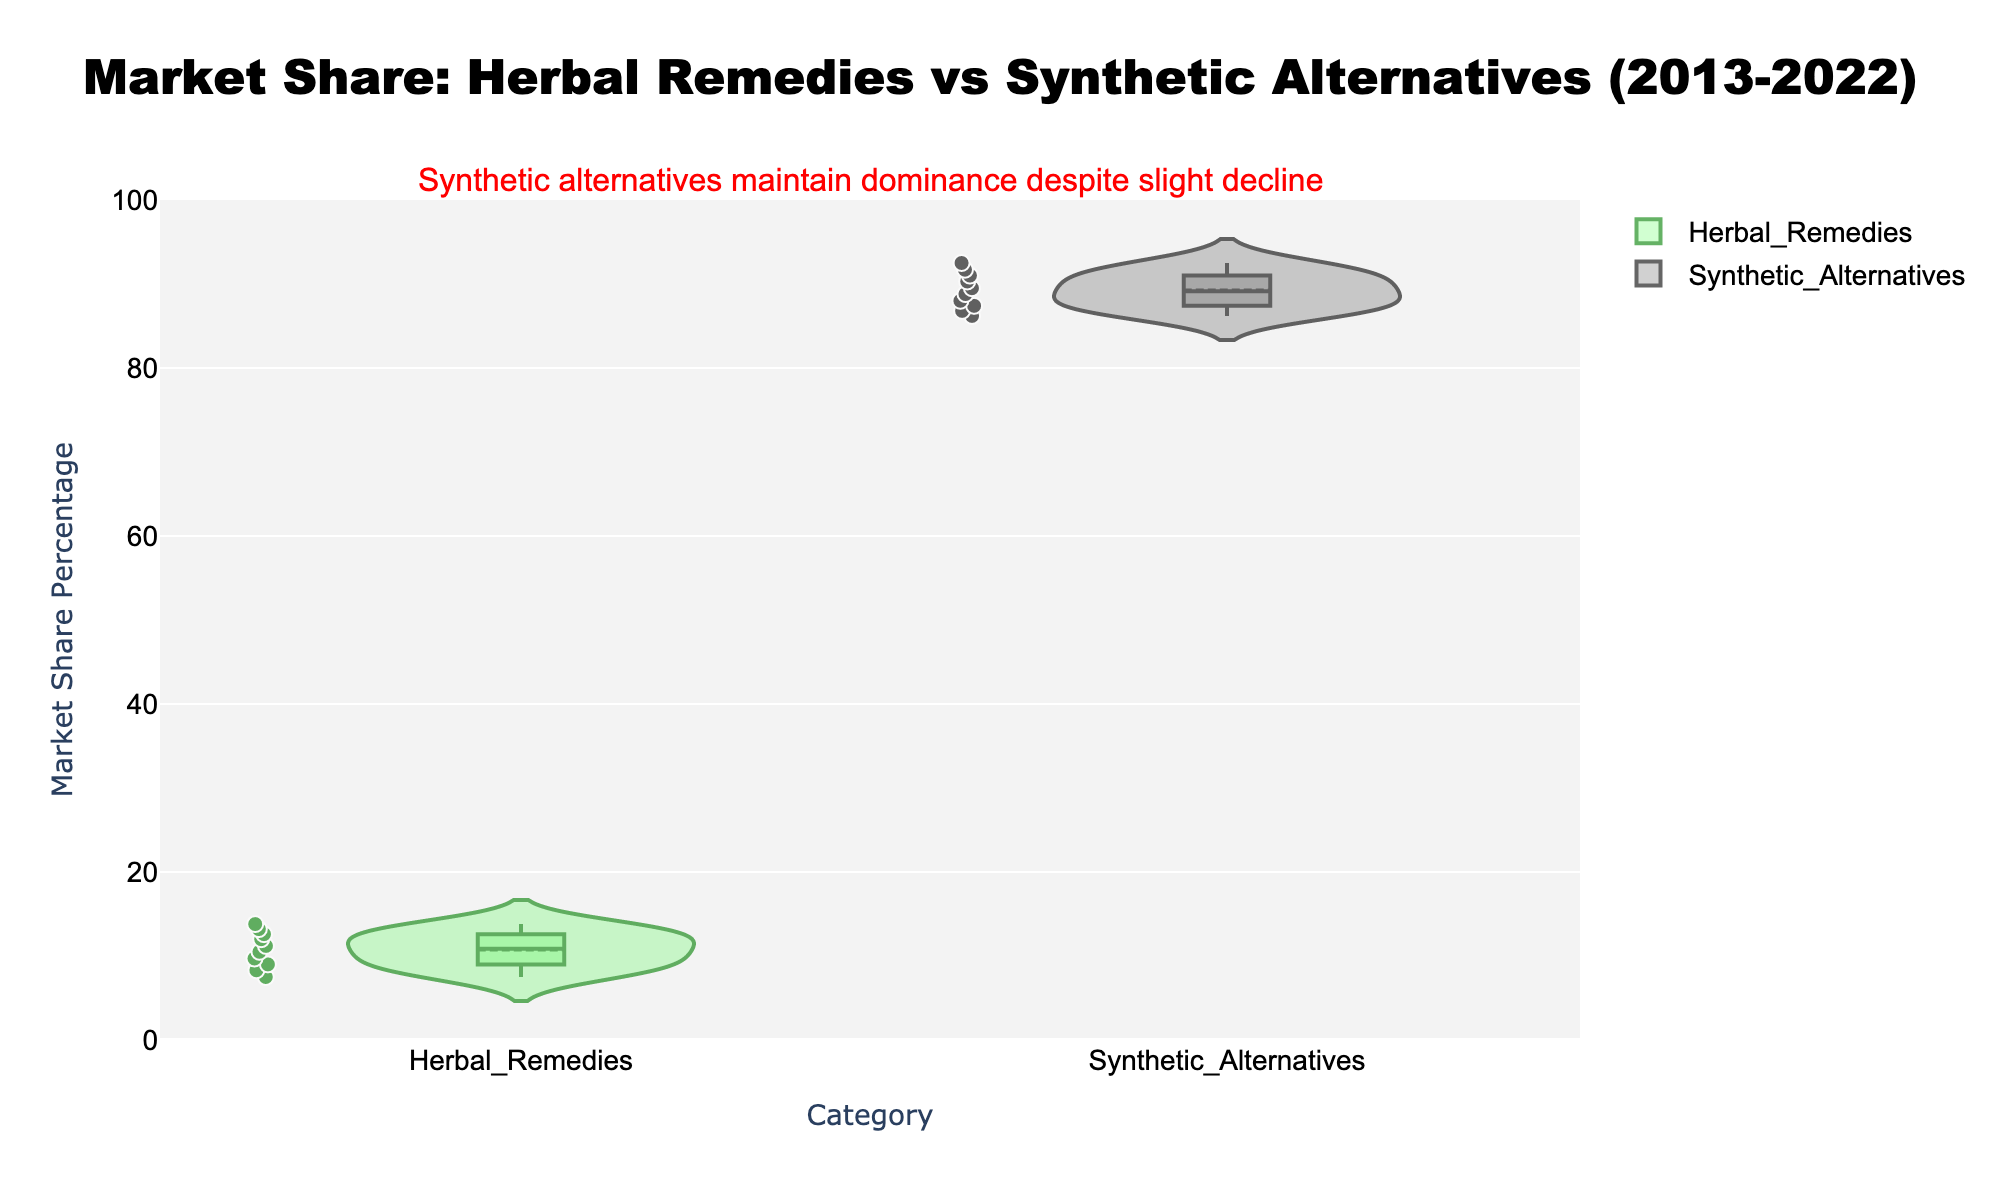What is the title of the figure? The title is typically found at the very top of the figure and describes what the plot is showing. In this case, we can see the title "Market Share: Herbal Remedies vs Synthetic Alternatives (2013-2022)".
Answer: Market Share: Herbal Remedies vs Synthetic Alternatives (2013-2022) What are the two categories compared in the figure? The x-axis of the figure represents the categories being compared, and in this case, they are labeled as "Herbal Remedies" and "Synthetic Alternatives".
Answer: Herbal Remedies and Synthetic Alternatives What is the trend in market share for Herbal Remedies over the years 2013 to 2022? By observing the box plot overlay within the violin plot for Herbal Remedies, we can see a general upward trend in market share percentages over the years. It starts from a lower distribution and gradually shifts upward.
Answer: Upward trend Which category has a higher market share percentage overall? The figure's y-axis indicates market share percentages, and by comparison, Synthetic Alternatives consistently have a higher market share percentage throughout the decade.
Answer: Synthetic Alternatives What is the color used to represent Synthetic Alternatives in the plot? The color of the lines and markers for Synthetic Alternatives is black, as specified in the visual design. The fill color is also greyish to denote a contrast with Herbal Remedies.
Answer: Black (with greyish fill) What is the mean market share percentage for Herbal Remedies as shown in the plot? The mean line is visible within the violin plot for Herbal Remedies. Observing its position, the mean market share percentage for Herbal Remedies over the decade is around 11.58%.
Answer: 11.58% How does the quartile distribution for Synthetic Alternatives compare to that of Herbal Remedies? The box plot within the violin plot shows the interquartile ranges: the boxes for Synthetic Alternatives are positioned higher with narrower distributions compared to those for Herbal Remedies, indicating less variability and higher values overall.
Answer: Higher and narrower distribution What is the interquartile range (IQR) for Herbal Remedies? The IQR for a box plot is found between the Q1 (lower quartile) and Q3 (upper quartile) values. For Herbal Remedies, the IQR spans from roughly 10 to 13 percentage points.
Answer: Around 3 percentage points What year did Herbal Remedies first exceed a 10% market share? By examining the plotted points for Herbal Remedies, we see that the market share first exceeds 10% in the year 2017.
Answer: 2017 Which annotation is used to provide additional insights into the plot? The annotation located at the top of the plot above the title provides an insight, mentioning "Synthetic alternatives maintain dominance despite slight decline".
Answer: Synthetic alternatives maintain dominance despite slight decline 